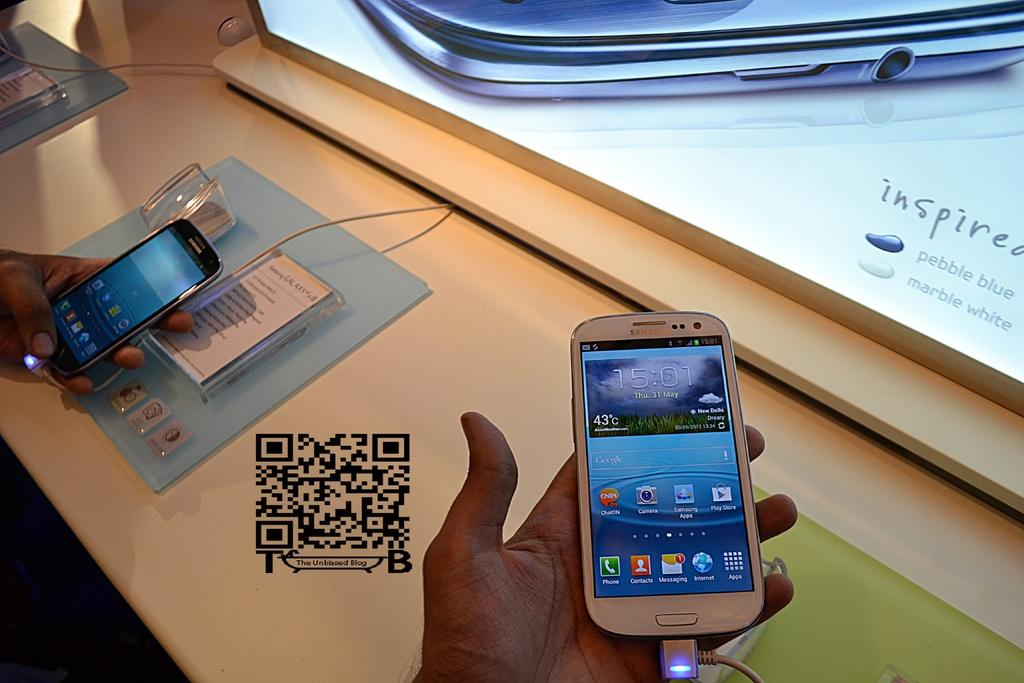<image>
Render a clear and concise summary of the photo. A man holds a Samsung phone at a kiosk with a QR code on the table. 